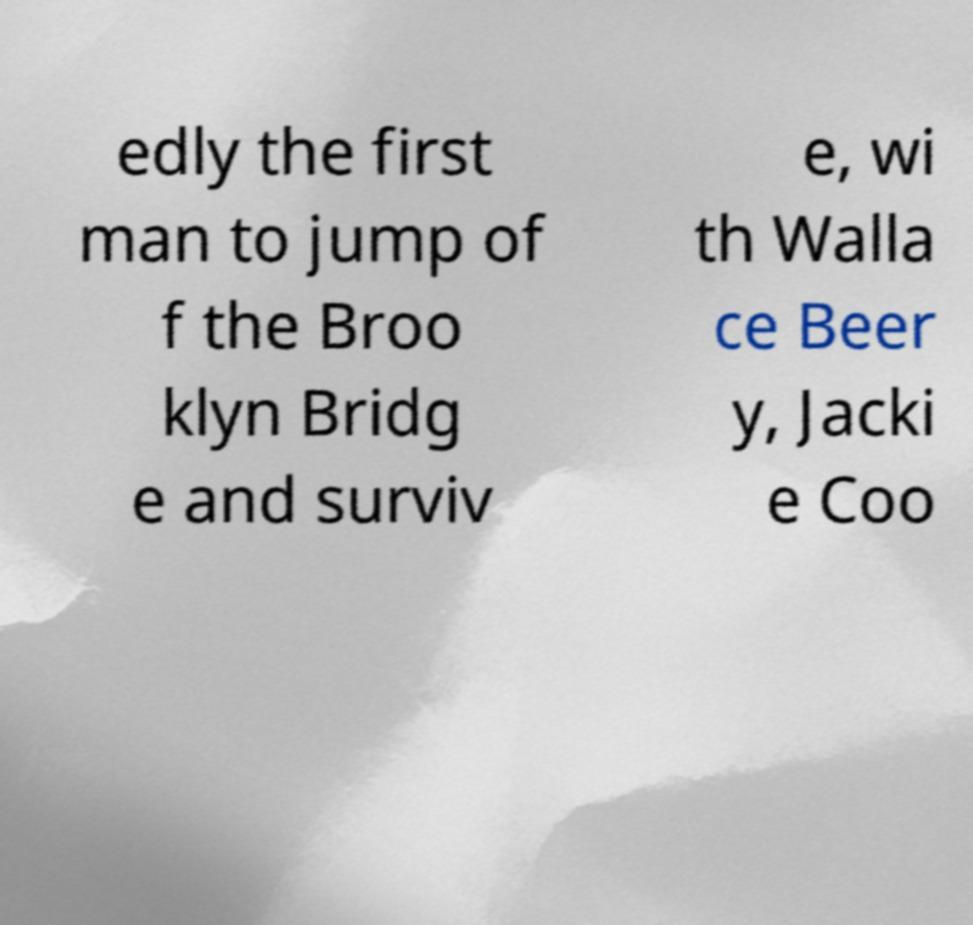For documentation purposes, I need the text within this image transcribed. Could you provide that? edly the first man to jump of f the Broo klyn Bridg e and surviv e, wi th Walla ce Beer y, Jacki e Coo 